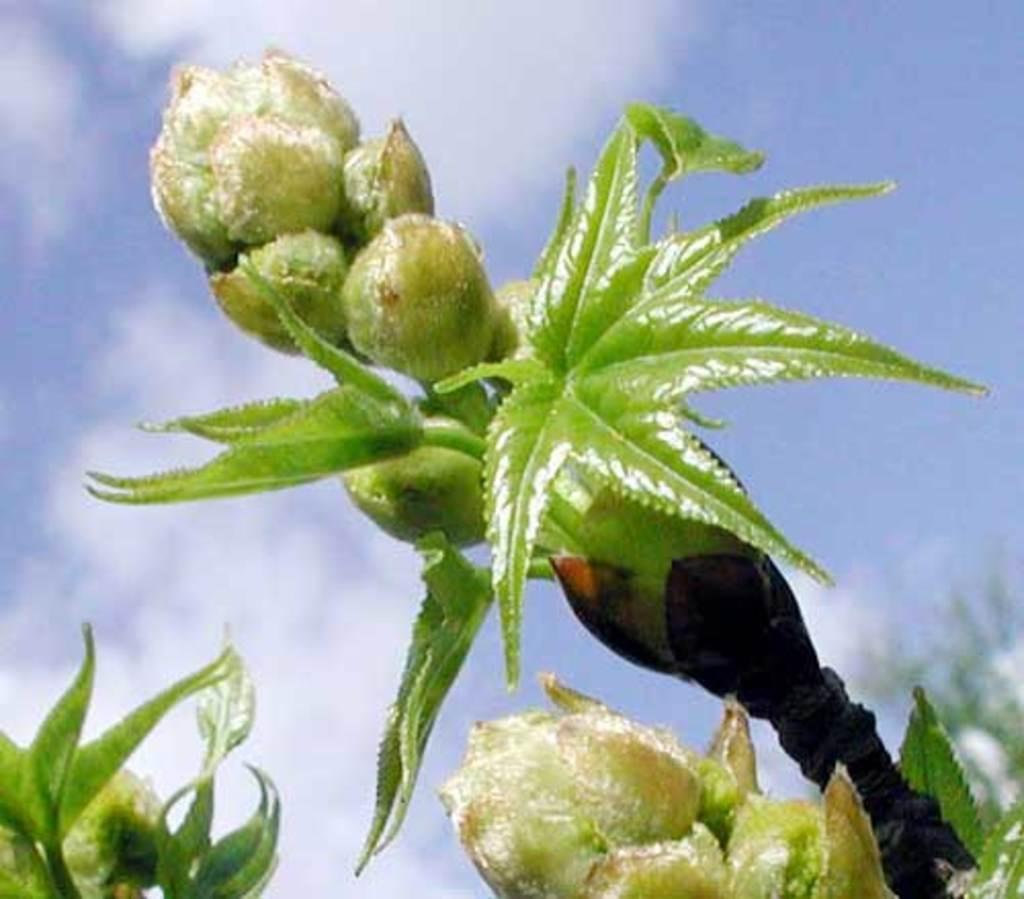What type of living organisms can be seen in the image? Plants can be seen in the image. What is visible in the background of the image? The sky is visible in the background of the image. What can be observed in the sky? There are clouds in the sky. Where is the shelf located in the image? There is no shelf present in the image. What type of vegetable can be seen growing in the image? There is no vegetable growing in the image; it only features plants. 